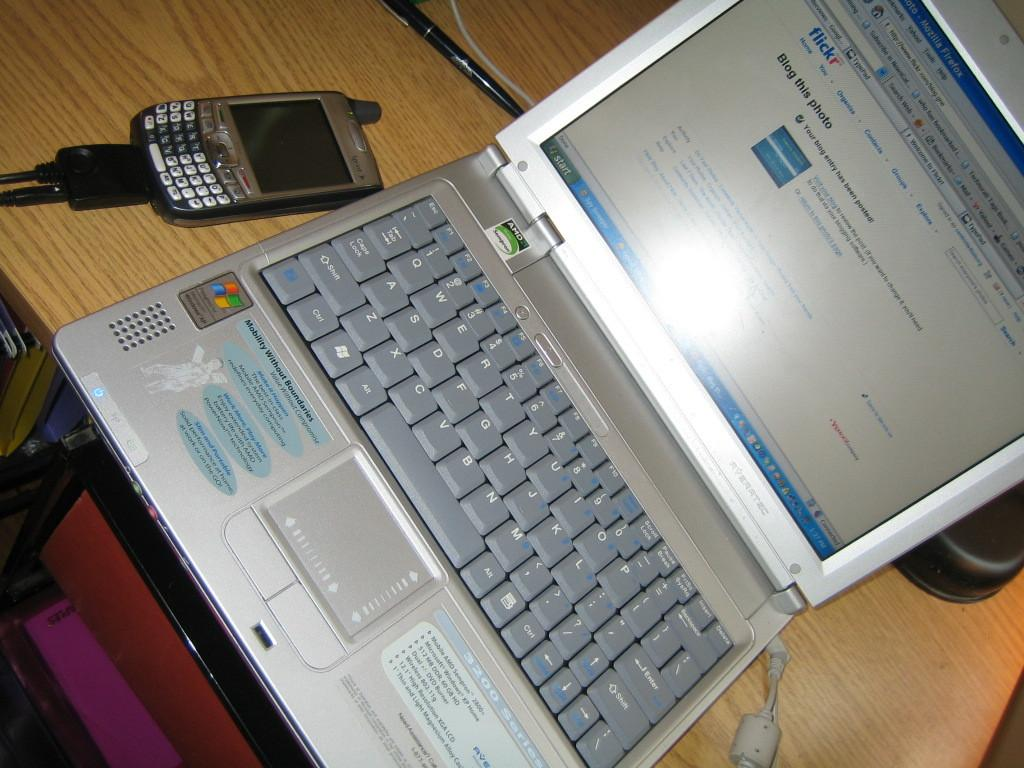<image>
Render a clear and concise summary of the photo. A windows laptop is open to the Flickr website.q 